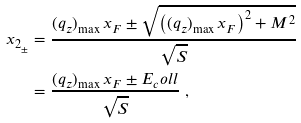Convert formula to latex. <formula><loc_0><loc_0><loc_500><loc_500>x _ { 2 _ { \pm } } & = \frac { ( q _ { z } ) _ { \max } \, x _ { F } \pm \sqrt { \left ( ( q _ { z } ) _ { \max } \, x _ { F } \right ) ^ { 2 } + M ^ { 2 } } } { \sqrt { S } } \\ & = \frac { ( q _ { z } ) _ { \max } \, x _ { F } \pm E _ { c } o l l } { \sqrt { S } } \ ,</formula> 